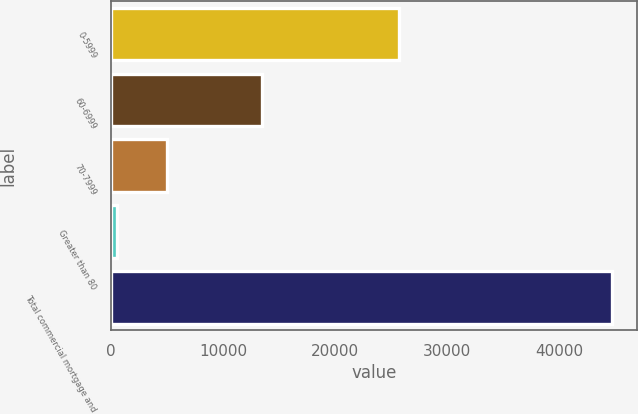Convert chart to OTSL. <chart><loc_0><loc_0><loc_500><loc_500><bar_chart><fcel>0-5999<fcel>60-6999<fcel>70-7999<fcel>Greater than 80<fcel>Total commercial mortgage and<nl><fcel>25695<fcel>13451<fcel>5039<fcel>563<fcel>44748<nl></chart> 